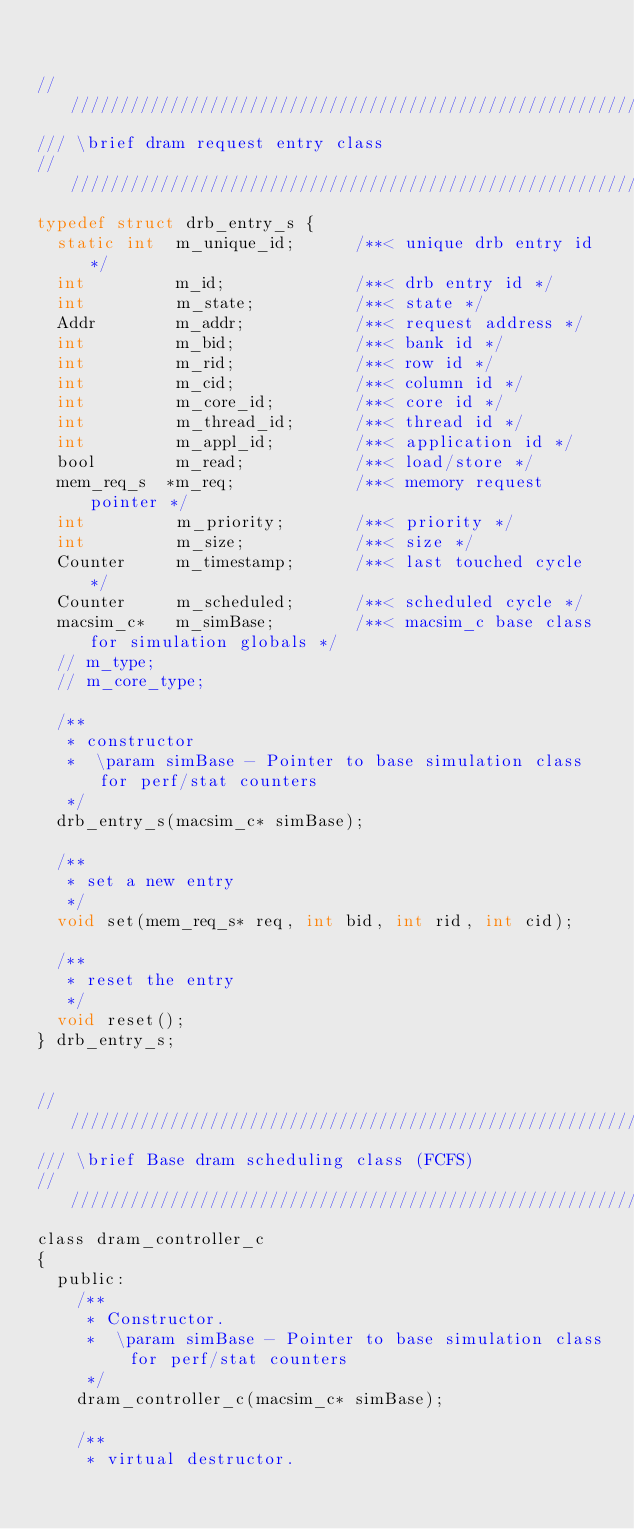<code> <loc_0><loc_0><loc_500><loc_500><_C_>

///////////////////////////////////////////////////////////////////////////////////////////////
/// \brief dram request entry class
///////////////////////////////////////////////////////////////////////////////////////////////
typedef struct drb_entry_s {
  static int  m_unique_id;      /**< unique drb entry id */
  int         m_id;             /**< drb entry id */
  int         m_state;          /**< state */
  Addr        m_addr;           /**< request address */
  int         m_bid;            /**< bank id */
  int         m_rid;            /**< row id */
  int         m_cid;            /**< column id */
  int         m_core_id;        /**< core id */
  int         m_thread_id;      /**< thread id */
  int         m_appl_id;        /**< application id */
  bool        m_read;           /**< load/store */
  mem_req_s  *m_req;            /**< memory request pointer */
  int         m_priority;       /**< priority */
  int         m_size;           /**< size */
  Counter     m_timestamp;      /**< last touched cycle */
  Counter     m_scheduled;      /**< scheduled cycle */
  macsim_c*   m_simBase;        /**< macsim_c base class for simulation globals */
  // m_type;
  // m_core_type;

  /**
   * constructor
   *  \param simBase - Pointer to base simulation class for perf/stat counters
   */
  drb_entry_s(macsim_c* simBase);

  /**
   * set a new entry
   */
  void set(mem_req_s* req, int bid, int rid, int cid);

  /**
   * reset the entry
   */
  void reset();
} drb_entry_s;


///////////////////////////////////////////////////////////////////////////////////////////////
/// \brief Base dram scheduling class (FCFS)
///////////////////////////////////////////////////////////////////////////////////////////////
class dram_controller_c
{
  public:
    /**
     * Constructor.
     *  \param simBase - Pointer to base simulation class for perf/stat counters
     */
    dram_controller_c(macsim_c* simBase);

    /**
     * virtual destructor.</code> 